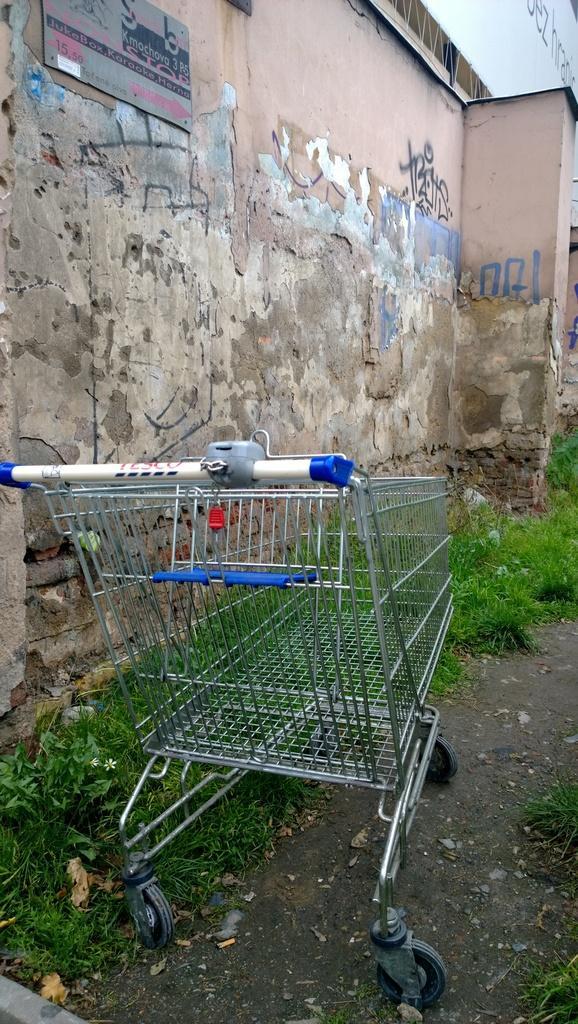In one or two sentences, can you explain what this image depicts? In the image there is a trolley on the land with grass beside it and followed by a wall. 